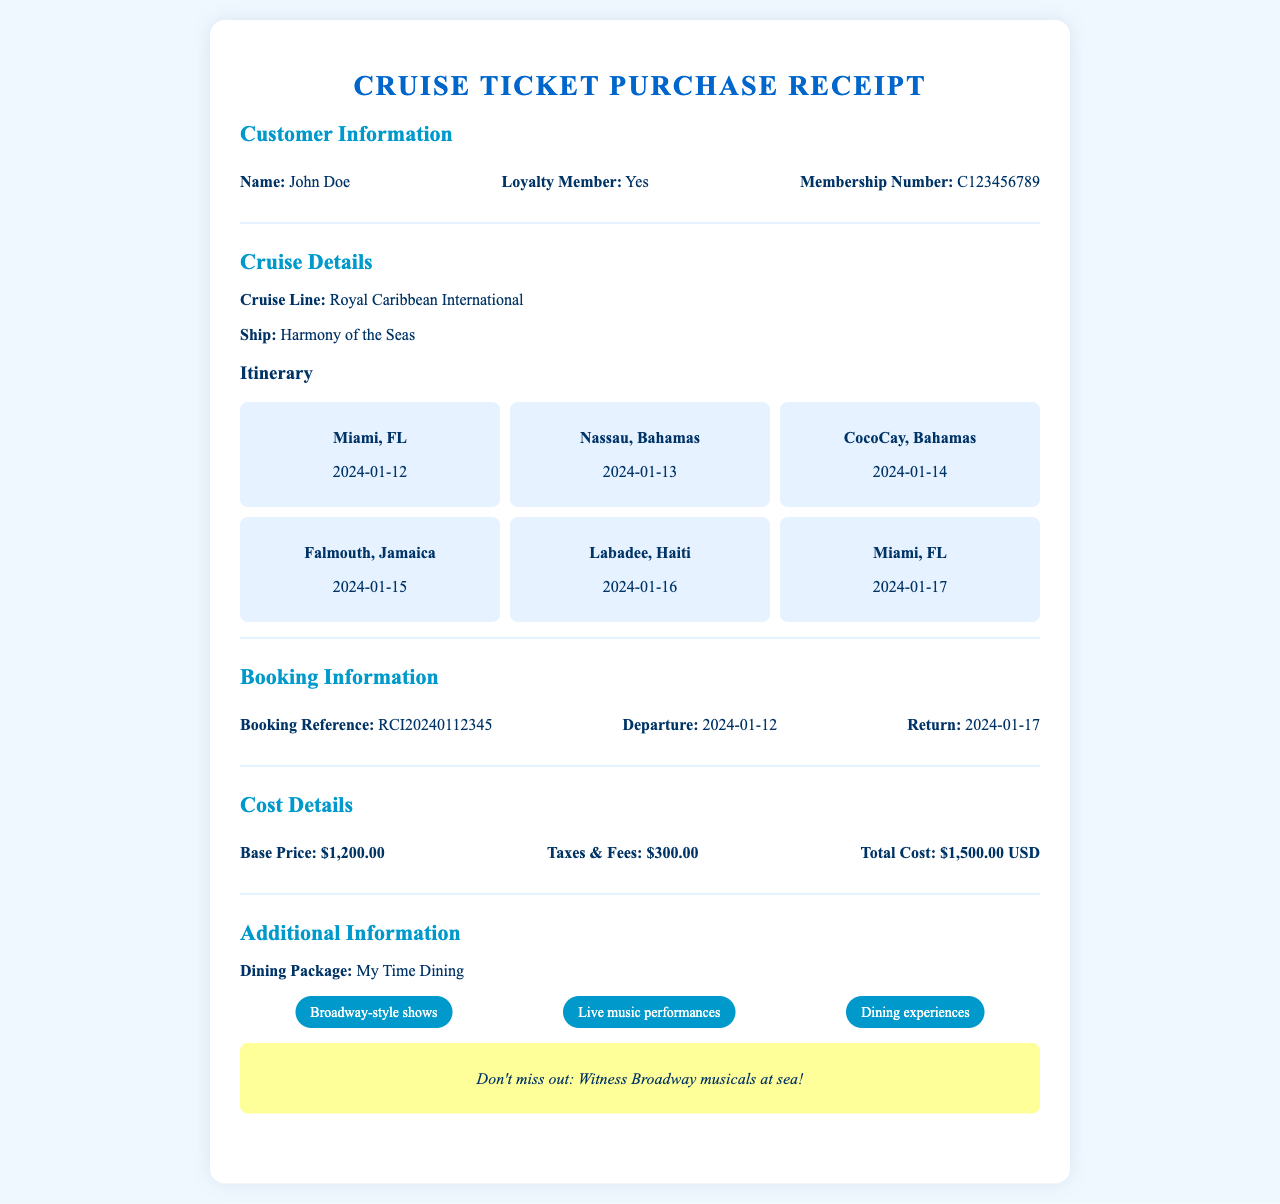What is the customer name? The customer's name is presented in the document as part of the customer information section.
Answer: John Doe What is the total cost of the cruise? The total cost is detailed in the cost details section of the receipt.
Answer: $1,500.00 USD What is the departure date? The departure date is specified in the booking information section.
Answer: 2024-01-12 How many ports are visited during the cruise? The itinerary section lists all the ports included in the cruise.
Answer: 6 What is the booking reference number? The booking reference number is part of the booking information section of the document.
Answer: RCI20240112345 Which ship is included in the cruise details? The ship name is mentioned in the cruise details section.
Answer: Harmony of the Seas What activities are highlighted in the additional information section? The additional information section mentions specific activities available during the cruise.
Answer: Broadway-style shows, Live music performances, Dining experiences What is the last port before returning? The itinerary indicates the last port visited before return is shown in the document.
Answer: Miami, FL 